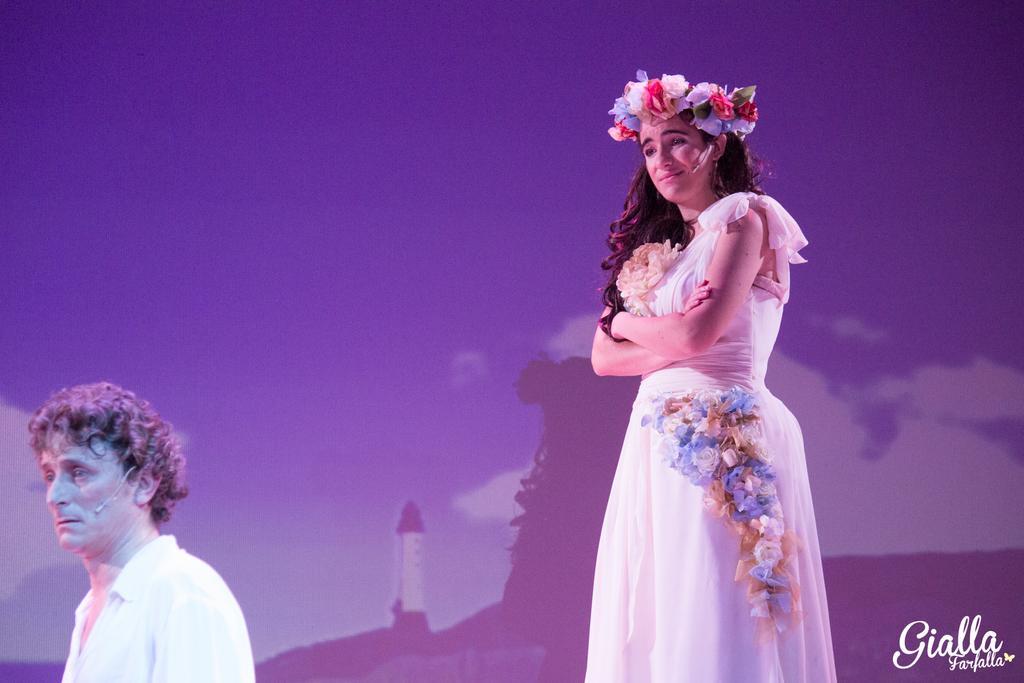How would you summarize this image in a sentence or two? In this image I can see two people. Among them one person is wearing the crown. 